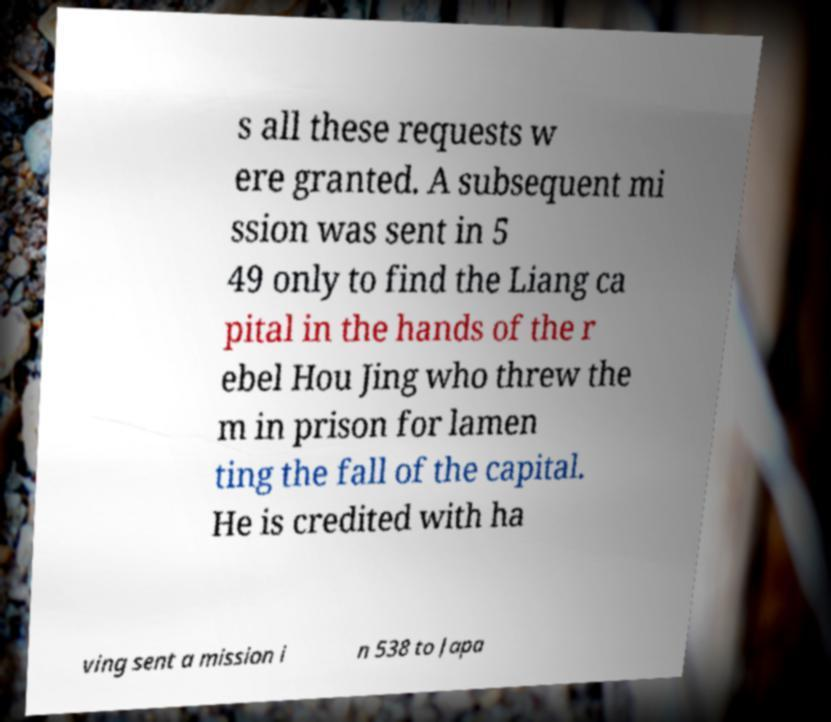Please identify and transcribe the text found in this image. s all these requests w ere granted. A subsequent mi ssion was sent in 5 49 only to find the Liang ca pital in the hands of the r ebel Hou Jing who threw the m in prison for lamen ting the fall of the capital. He is credited with ha ving sent a mission i n 538 to Japa 